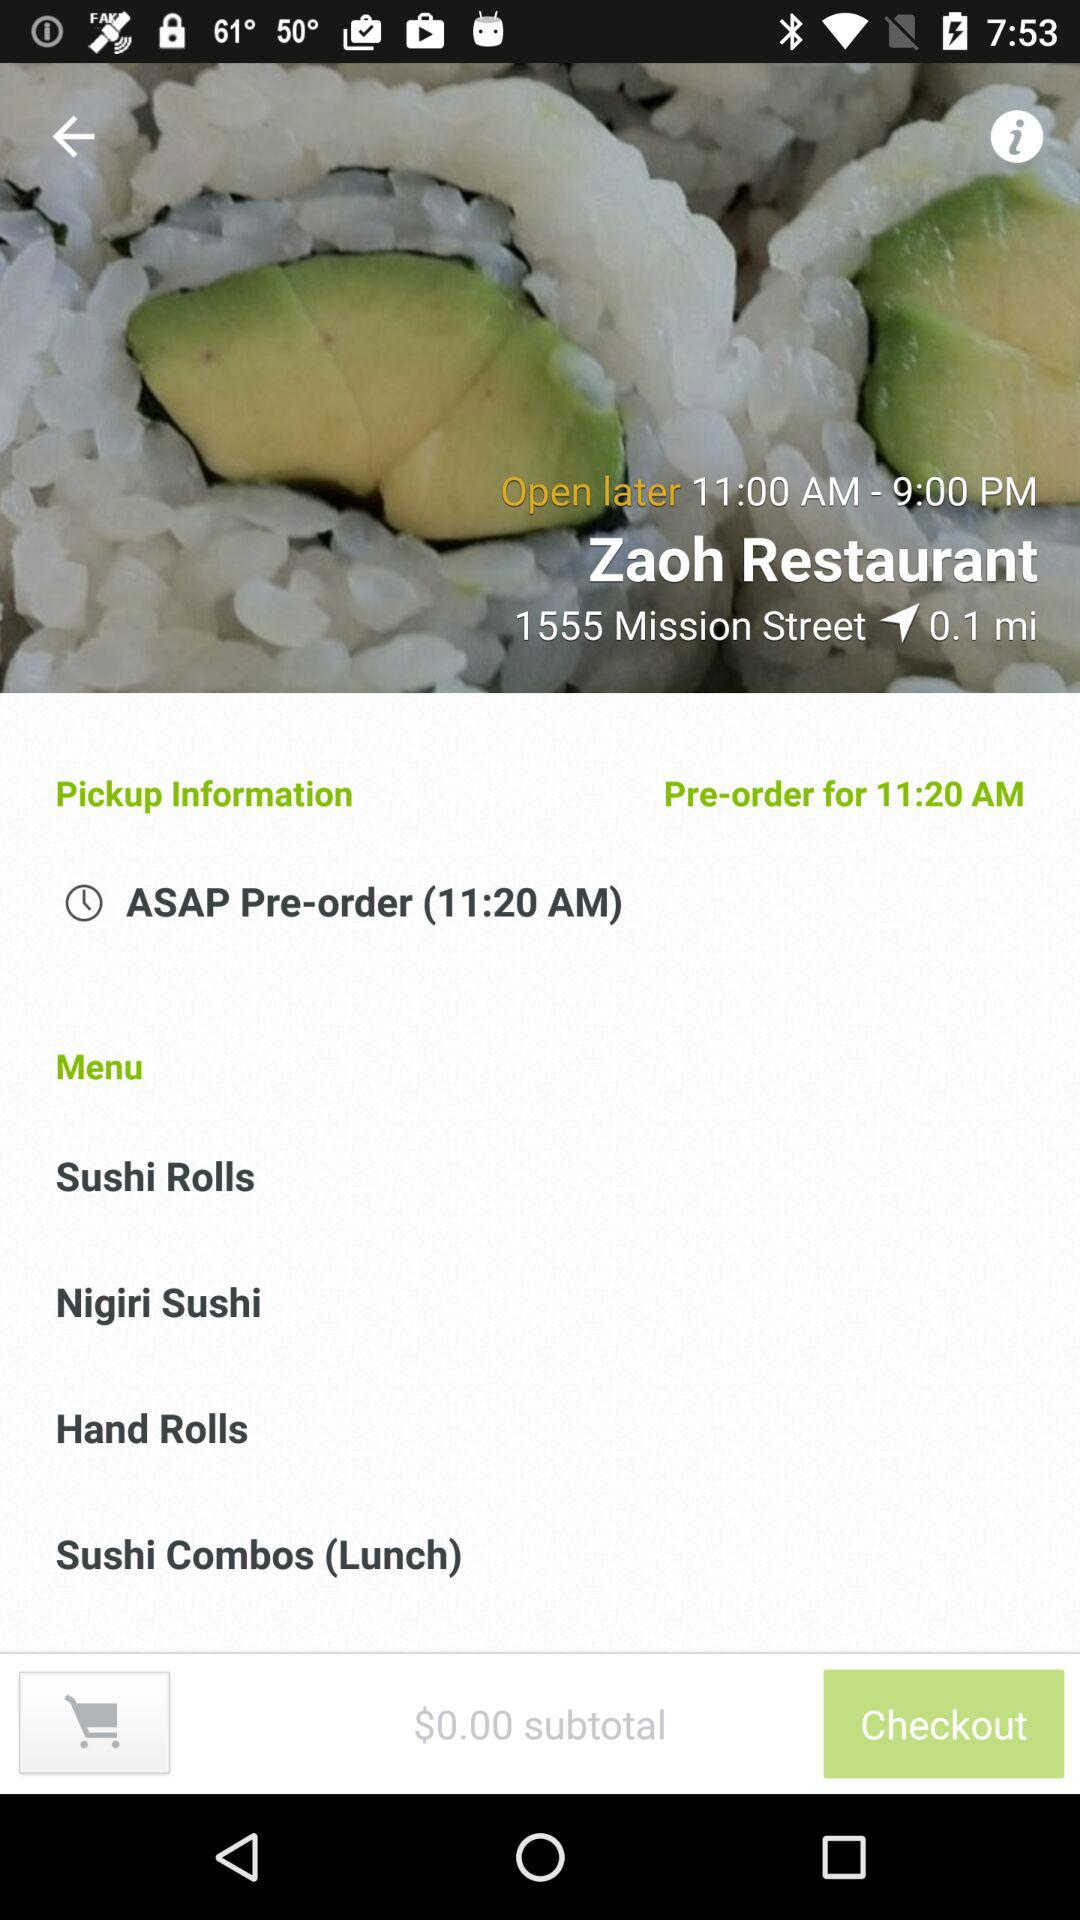What is the open time of Zaoh Restaurant? The opening time of Zaoh Restaurant is 11:00 AM to 9:00 PM. 